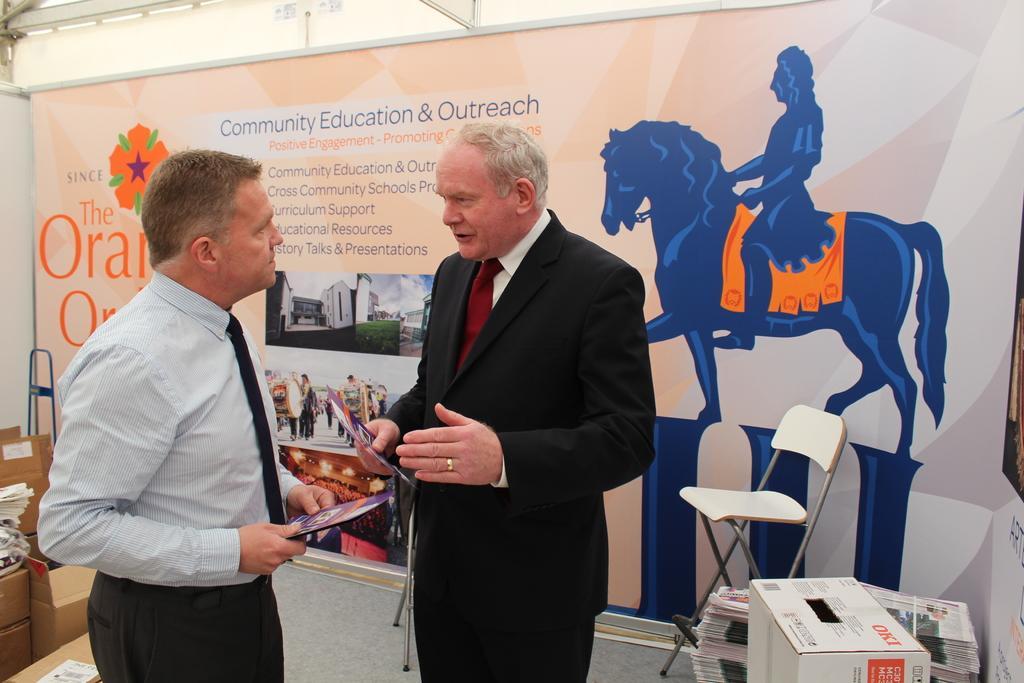How would you summarize this image in a sentence or two? In this picture I can see couple of men standing and looks like a man is talking and they are holding papers in their hands and I can see few carton boxes on the left side and I can see a chair and few papers and a box on the right side and I can see an advertisement hoarding in the back with some text and pictures. 